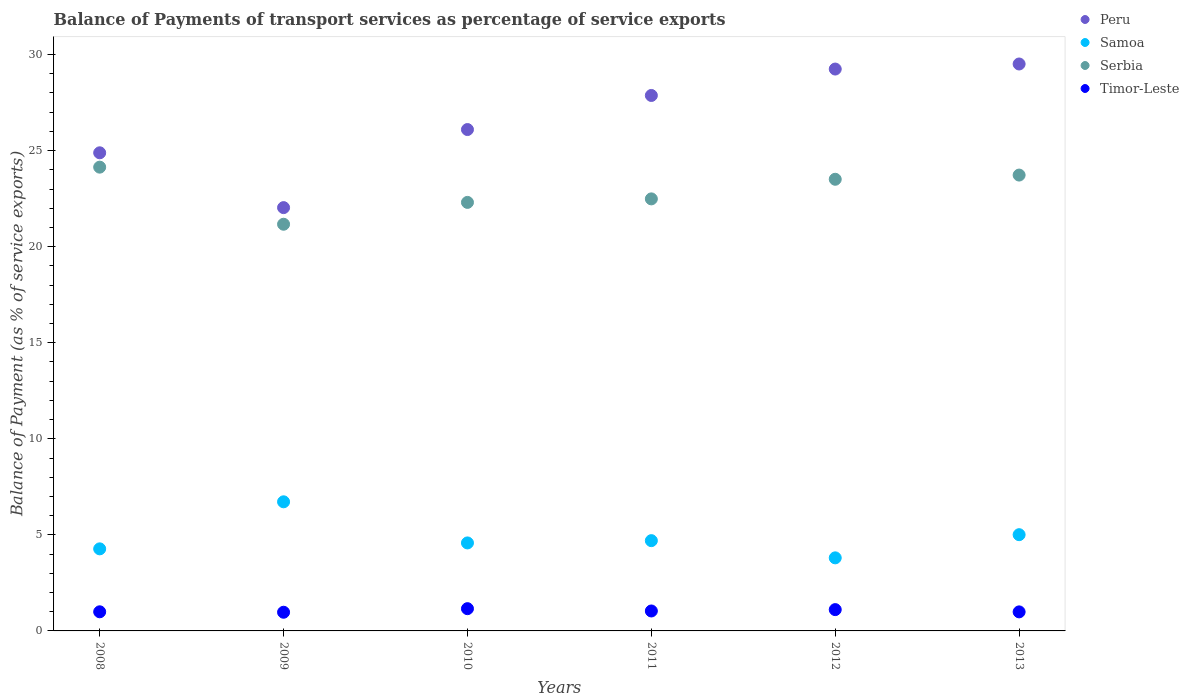Is the number of dotlines equal to the number of legend labels?
Your answer should be very brief. Yes. What is the balance of payments of transport services in Serbia in 2010?
Your answer should be compact. 22.3. Across all years, what is the maximum balance of payments of transport services in Samoa?
Provide a succinct answer. 6.72. Across all years, what is the minimum balance of payments of transport services in Peru?
Your answer should be very brief. 22.03. In which year was the balance of payments of transport services in Peru minimum?
Provide a short and direct response. 2009. What is the total balance of payments of transport services in Samoa in the graph?
Ensure brevity in your answer.  29.08. What is the difference between the balance of payments of transport services in Samoa in 2011 and that in 2013?
Give a very brief answer. -0.31. What is the difference between the balance of payments of transport services in Peru in 2011 and the balance of payments of transport services in Samoa in 2012?
Keep it short and to the point. 24.07. What is the average balance of payments of transport services in Samoa per year?
Offer a terse response. 4.85. In the year 2011, what is the difference between the balance of payments of transport services in Samoa and balance of payments of transport services in Peru?
Give a very brief answer. -23.17. What is the ratio of the balance of payments of transport services in Timor-Leste in 2010 to that in 2012?
Your answer should be compact. 1.04. Is the balance of payments of transport services in Serbia in 2010 less than that in 2013?
Offer a terse response. Yes. What is the difference between the highest and the second highest balance of payments of transport services in Peru?
Make the answer very short. 0.26. What is the difference between the highest and the lowest balance of payments of transport services in Peru?
Your answer should be very brief. 7.48. In how many years, is the balance of payments of transport services in Samoa greater than the average balance of payments of transport services in Samoa taken over all years?
Offer a terse response. 2. Is the sum of the balance of payments of transport services in Samoa in 2012 and 2013 greater than the maximum balance of payments of transport services in Timor-Leste across all years?
Offer a very short reply. Yes. How many years are there in the graph?
Ensure brevity in your answer.  6. What is the difference between two consecutive major ticks on the Y-axis?
Give a very brief answer. 5. Does the graph contain any zero values?
Ensure brevity in your answer.  No. Where does the legend appear in the graph?
Offer a very short reply. Top right. What is the title of the graph?
Make the answer very short. Balance of Payments of transport services as percentage of service exports. What is the label or title of the Y-axis?
Ensure brevity in your answer.  Balance of Payment (as % of service exports). What is the Balance of Payment (as % of service exports) of Peru in 2008?
Your answer should be compact. 24.88. What is the Balance of Payment (as % of service exports) of Samoa in 2008?
Provide a succinct answer. 4.27. What is the Balance of Payment (as % of service exports) of Serbia in 2008?
Provide a succinct answer. 24.14. What is the Balance of Payment (as % of service exports) in Timor-Leste in 2008?
Provide a succinct answer. 1. What is the Balance of Payment (as % of service exports) of Peru in 2009?
Give a very brief answer. 22.03. What is the Balance of Payment (as % of service exports) in Samoa in 2009?
Provide a short and direct response. 6.72. What is the Balance of Payment (as % of service exports) of Serbia in 2009?
Make the answer very short. 21.17. What is the Balance of Payment (as % of service exports) in Timor-Leste in 2009?
Offer a terse response. 0.97. What is the Balance of Payment (as % of service exports) in Peru in 2010?
Your answer should be very brief. 26.09. What is the Balance of Payment (as % of service exports) in Samoa in 2010?
Ensure brevity in your answer.  4.58. What is the Balance of Payment (as % of service exports) of Serbia in 2010?
Provide a short and direct response. 22.3. What is the Balance of Payment (as % of service exports) of Timor-Leste in 2010?
Offer a terse response. 1.16. What is the Balance of Payment (as % of service exports) in Peru in 2011?
Offer a very short reply. 27.87. What is the Balance of Payment (as % of service exports) of Samoa in 2011?
Make the answer very short. 4.7. What is the Balance of Payment (as % of service exports) in Serbia in 2011?
Offer a very short reply. 22.49. What is the Balance of Payment (as % of service exports) in Timor-Leste in 2011?
Make the answer very short. 1.04. What is the Balance of Payment (as % of service exports) in Peru in 2012?
Provide a short and direct response. 29.24. What is the Balance of Payment (as % of service exports) of Samoa in 2012?
Your answer should be compact. 3.8. What is the Balance of Payment (as % of service exports) of Serbia in 2012?
Make the answer very short. 23.51. What is the Balance of Payment (as % of service exports) of Timor-Leste in 2012?
Ensure brevity in your answer.  1.11. What is the Balance of Payment (as % of service exports) of Peru in 2013?
Your answer should be very brief. 29.51. What is the Balance of Payment (as % of service exports) of Samoa in 2013?
Provide a succinct answer. 5.01. What is the Balance of Payment (as % of service exports) of Serbia in 2013?
Your answer should be very brief. 23.73. What is the Balance of Payment (as % of service exports) in Timor-Leste in 2013?
Provide a short and direct response. 0.99. Across all years, what is the maximum Balance of Payment (as % of service exports) in Peru?
Make the answer very short. 29.51. Across all years, what is the maximum Balance of Payment (as % of service exports) of Samoa?
Provide a short and direct response. 6.72. Across all years, what is the maximum Balance of Payment (as % of service exports) in Serbia?
Make the answer very short. 24.14. Across all years, what is the maximum Balance of Payment (as % of service exports) in Timor-Leste?
Ensure brevity in your answer.  1.16. Across all years, what is the minimum Balance of Payment (as % of service exports) in Peru?
Your answer should be compact. 22.03. Across all years, what is the minimum Balance of Payment (as % of service exports) of Samoa?
Give a very brief answer. 3.8. Across all years, what is the minimum Balance of Payment (as % of service exports) in Serbia?
Your answer should be compact. 21.17. Across all years, what is the minimum Balance of Payment (as % of service exports) in Timor-Leste?
Your answer should be compact. 0.97. What is the total Balance of Payment (as % of service exports) of Peru in the graph?
Offer a terse response. 159.63. What is the total Balance of Payment (as % of service exports) of Samoa in the graph?
Offer a terse response. 29.08. What is the total Balance of Payment (as % of service exports) of Serbia in the graph?
Make the answer very short. 137.33. What is the total Balance of Payment (as % of service exports) of Timor-Leste in the graph?
Your response must be concise. 6.26. What is the difference between the Balance of Payment (as % of service exports) in Peru in 2008 and that in 2009?
Your response must be concise. 2.85. What is the difference between the Balance of Payment (as % of service exports) in Samoa in 2008 and that in 2009?
Provide a succinct answer. -2.45. What is the difference between the Balance of Payment (as % of service exports) in Serbia in 2008 and that in 2009?
Make the answer very short. 2.97. What is the difference between the Balance of Payment (as % of service exports) in Timor-Leste in 2008 and that in 2009?
Make the answer very short. 0.02. What is the difference between the Balance of Payment (as % of service exports) of Peru in 2008 and that in 2010?
Your response must be concise. -1.21. What is the difference between the Balance of Payment (as % of service exports) in Samoa in 2008 and that in 2010?
Ensure brevity in your answer.  -0.31. What is the difference between the Balance of Payment (as % of service exports) of Serbia in 2008 and that in 2010?
Offer a terse response. 1.83. What is the difference between the Balance of Payment (as % of service exports) of Timor-Leste in 2008 and that in 2010?
Offer a terse response. -0.16. What is the difference between the Balance of Payment (as % of service exports) in Peru in 2008 and that in 2011?
Provide a succinct answer. -2.98. What is the difference between the Balance of Payment (as % of service exports) in Samoa in 2008 and that in 2011?
Give a very brief answer. -0.43. What is the difference between the Balance of Payment (as % of service exports) of Serbia in 2008 and that in 2011?
Keep it short and to the point. 1.65. What is the difference between the Balance of Payment (as % of service exports) of Timor-Leste in 2008 and that in 2011?
Give a very brief answer. -0.04. What is the difference between the Balance of Payment (as % of service exports) in Peru in 2008 and that in 2012?
Your response must be concise. -4.36. What is the difference between the Balance of Payment (as % of service exports) of Samoa in 2008 and that in 2012?
Offer a terse response. 0.47. What is the difference between the Balance of Payment (as % of service exports) of Serbia in 2008 and that in 2012?
Offer a very short reply. 0.63. What is the difference between the Balance of Payment (as % of service exports) of Timor-Leste in 2008 and that in 2012?
Your response must be concise. -0.11. What is the difference between the Balance of Payment (as % of service exports) in Peru in 2008 and that in 2013?
Provide a short and direct response. -4.62. What is the difference between the Balance of Payment (as % of service exports) of Samoa in 2008 and that in 2013?
Your answer should be compact. -0.74. What is the difference between the Balance of Payment (as % of service exports) of Serbia in 2008 and that in 2013?
Your answer should be very brief. 0.41. What is the difference between the Balance of Payment (as % of service exports) in Timor-Leste in 2008 and that in 2013?
Your answer should be compact. 0. What is the difference between the Balance of Payment (as % of service exports) of Peru in 2009 and that in 2010?
Ensure brevity in your answer.  -4.06. What is the difference between the Balance of Payment (as % of service exports) of Samoa in 2009 and that in 2010?
Make the answer very short. 2.14. What is the difference between the Balance of Payment (as % of service exports) in Serbia in 2009 and that in 2010?
Offer a very short reply. -1.14. What is the difference between the Balance of Payment (as % of service exports) in Timor-Leste in 2009 and that in 2010?
Make the answer very short. -0.19. What is the difference between the Balance of Payment (as % of service exports) in Peru in 2009 and that in 2011?
Make the answer very short. -5.84. What is the difference between the Balance of Payment (as % of service exports) of Samoa in 2009 and that in 2011?
Keep it short and to the point. 2.02. What is the difference between the Balance of Payment (as % of service exports) of Serbia in 2009 and that in 2011?
Your answer should be very brief. -1.32. What is the difference between the Balance of Payment (as % of service exports) in Timor-Leste in 2009 and that in 2011?
Offer a very short reply. -0.07. What is the difference between the Balance of Payment (as % of service exports) of Peru in 2009 and that in 2012?
Provide a short and direct response. -7.21. What is the difference between the Balance of Payment (as % of service exports) of Samoa in 2009 and that in 2012?
Make the answer very short. 2.92. What is the difference between the Balance of Payment (as % of service exports) in Serbia in 2009 and that in 2012?
Your answer should be compact. -2.34. What is the difference between the Balance of Payment (as % of service exports) in Timor-Leste in 2009 and that in 2012?
Your answer should be compact. -0.14. What is the difference between the Balance of Payment (as % of service exports) of Peru in 2009 and that in 2013?
Offer a terse response. -7.48. What is the difference between the Balance of Payment (as % of service exports) in Samoa in 2009 and that in 2013?
Your response must be concise. 1.71. What is the difference between the Balance of Payment (as % of service exports) in Serbia in 2009 and that in 2013?
Offer a terse response. -2.56. What is the difference between the Balance of Payment (as % of service exports) of Timor-Leste in 2009 and that in 2013?
Your answer should be compact. -0.02. What is the difference between the Balance of Payment (as % of service exports) of Peru in 2010 and that in 2011?
Offer a very short reply. -1.77. What is the difference between the Balance of Payment (as % of service exports) in Samoa in 2010 and that in 2011?
Provide a short and direct response. -0.12. What is the difference between the Balance of Payment (as % of service exports) of Serbia in 2010 and that in 2011?
Provide a short and direct response. -0.18. What is the difference between the Balance of Payment (as % of service exports) of Timor-Leste in 2010 and that in 2011?
Give a very brief answer. 0.12. What is the difference between the Balance of Payment (as % of service exports) in Peru in 2010 and that in 2012?
Your answer should be very brief. -3.15. What is the difference between the Balance of Payment (as % of service exports) in Samoa in 2010 and that in 2012?
Your response must be concise. 0.78. What is the difference between the Balance of Payment (as % of service exports) of Serbia in 2010 and that in 2012?
Your answer should be compact. -1.2. What is the difference between the Balance of Payment (as % of service exports) of Timor-Leste in 2010 and that in 2012?
Offer a very short reply. 0.05. What is the difference between the Balance of Payment (as % of service exports) in Peru in 2010 and that in 2013?
Your answer should be very brief. -3.41. What is the difference between the Balance of Payment (as % of service exports) of Samoa in 2010 and that in 2013?
Offer a terse response. -0.43. What is the difference between the Balance of Payment (as % of service exports) of Serbia in 2010 and that in 2013?
Provide a short and direct response. -1.42. What is the difference between the Balance of Payment (as % of service exports) of Timor-Leste in 2010 and that in 2013?
Ensure brevity in your answer.  0.17. What is the difference between the Balance of Payment (as % of service exports) of Peru in 2011 and that in 2012?
Offer a very short reply. -1.38. What is the difference between the Balance of Payment (as % of service exports) in Samoa in 2011 and that in 2012?
Keep it short and to the point. 0.9. What is the difference between the Balance of Payment (as % of service exports) of Serbia in 2011 and that in 2012?
Ensure brevity in your answer.  -1.02. What is the difference between the Balance of Payment (as % of service exports) in Timor-Leste in 2011 and that in 2012?
Offer a terse response. -0.07. What is the difference between the Balance of Payment (as % of service exports) in Peru in 2011 and that in 2013?
Offer a very short reply. -1.64. What is the difference between the Balance of Payment (as % of service exports) in Samoa in 2011 and that in 2013?
Make the answer very short. -0.31. What is the difference between the Balance of Payment (as % of service exports) of Serbia in 2011 and that in 2013?
Your answer should be compact. -1.24. What is the difference between the Balance of Payment (as % of service exports) in Timor-Leste in 2011 and that in 2013?
Give a very brief answer. 0.05. What is the difference between the Balance of Payment (as % of service exports) in Peru in 2012 and that in 2013?
Provide a short and direct response. -0.26. What is the difference between the Balance of Payment (as % of service exports) in Samoa in 2012 and that in 2013?
Your answer should be compact. -1.21. What is the difference between the Balance of Payment (as % of service exports) in Serbia in 2012 and that in 2013?
Offer a very short reply. -0.22. What is the difference between the Balance of Payment (as % of service exports) in Timor-Leste in 2012 and that in 2013?
Keep it short and to the point. 0.12. What is the difference between the Balance of Payment (as % of service exports) in Peru in 2008 and the Balance of Payment (as % of service exports) in Samoa in 2009?
Make the answer very short. 18.16. What is the difference between the Balance of Payment (as % of service exports) of Peru in 2008 and the Balance of Payment (as % of service exports) of Serbia in 2009?
Your response must be concise. 3.72. What is the difference between the Balance of Payment (as % of service exports) in Peru in 2008 and the Balance of Payment (as % of service exports) in Timor-Leste in 2009?
Offer a terse response. 23.91. What is the difference between the Balance of Payment (as % of service exports) of Samoa in 2008 and the Balance of Payment (as % of service exports) of Serbia in 2009?
Your answer should be very brief. -16.9. What is the difference between the Balance of Payment (as % of service exports) in Samoa in 2008 and the Balance of Payment (as % of service exports) in Timor-Leste in 2009?
Provide a succinct answer. 3.3. What is the difference between the Balance of Payment (as % of service exports) in Serbia in 2008 and the Balance of Payment (as % of service exports) in Timor-Leste in 2009?
Keep it short and to the point. 23.17. What is the difference between the Balance of Payment (as % of service exports) of Peru in 2008 and the Balance of Payment (as % of service exports) of Samoa in 2010?
Ensure brevity in your answer.  20.3. What is the difference between the Balance of Payment (as % of service exports) in Peru in 2008 and the Balance of Payment (as % of service exports) in Serbia in 2010?
Provide a short and direct response. 2.58. What is the difference between the Balance of Payment (as % of service exports) of Peru in 2008 and the Balance of Payment (as % of service exports) of Timor-Leste in 2010?
Provide a succinct answer. 23.73. What is the difference between the Balance of Payment (as % of service exports) in Samoa in 2008 and the Balance of Payment (as % of service exports) in Serbia in 2010?
Provide a short and direct response. -18.03. What is the difference between the Balance of Payment (as % of service exports) in Samoa in 2008 and the Balance of Payment (as % of service exports) in Timor-Leste in 2010?
Provide a succinct answer. 3.11. What is the difference between the Balance of Payment (as % of service exports) in Serbia in 2008 and the Balance of Payment (as % of service exports) in Timor-Leste in 2010?
Your response must be concise. 22.98. What is the difference between the Balance of Payment (as % of service exports) of Peru in 2008 and the Balance of Payment (as % of service exports) of Samoa in 2011?
Make the answer very short. 20.19. What is the difference between the Balance of Payment (as % of service exports) in Peru in 2008 and the Balance of Payment (as % of service exports) in Serbia in 2011?
Ensure brevity in your answer.  2.4. What is the difference between the Balance of Payment (as % of service exports) of Peru in 2008 and the Balance of Payment (as % of service exports) of Timor-Leste in 2011?
Provide a succinct answer. 23.85. What is the difference between the Balance of Payment (as % of service exports) in Samoa in 2008 and the Balance of Payment (as % of service exports) in Serbia in 2011?
Provide a short and direct response. -18.22. What is the difference between the Balance of Payment (as % of service exports) in Samoa in 2008 and the Balance of Payment (as % of service exports) in Timor-Leste in 2011?
Provide a short and direct response. 3.23. What is the difference between the Balance of Payment (as % of service exports) of Serbia in 2008 and the Balance of Payment (as % of service exports) of Timor-Leste in 2011?
Offer a terse response. 23.1. What is the difference between the Balance of Payment (as % of service exports) of Peru in 2008 and the Balance of Payment (as % of service exports) of Samoa in 2012?
Make the answer very short. 21.08. What is the difference between the Balance of Payment (as % of service exports) in Peru in 2008 and the Balance of Payment (as % of service exports) in Serbia in 2012?
Your answer should be very brief. 1.38. What is the difference between the Balance of Payment (as % of service exports) of Peru in 2008 and the Balance of Payment (as % of service exports) of Timor-Leste in 2012?
Offer a very short reply. 23.78. What is the difference between the Balance of Payment (as % of service exports) of Samoa in 2008 and the Balance of Payment (as % of service exports) of Serbia in 2012?
Keep it short and to the point. -19.24. What is the difference between the Balance of Payment (as % of service exports) in Samoa in 2008 and the Balance of Payment (as % of service exports) in Timor-Leste in 2012?
Offer a very short reply. 3.16. What is the difference between the Balance of Payment (as % of service exports) of Serbia in 2008 and the Balance of Payment (as % of service exports) of Timor-Leste in 2012?
Ensure brevity in your answer.  23.03. What is the difference between the Balance of Payment (as % of service exports) in Peru in 2008 and the Balance of Payment (as % of service exports) in Samoa in 2013?
Make the answer very short. 19.88. What is the difference between the Balance of Payment (as % of service exports) of Peru in 2008 and the Balance of Payment (as % of service exports) of Serbia in 2013?
Provide a short and direct response. 1.16. What is the difference between the Balance of Payment (as % of service exports) in Peru in 2008 and the Balance of Payment (as % of service exports) in Timor-Leste in 2013?
Your answer should be compact. 23.89. What is the difference between the Balance of Payment (as % of service exports) of Samoa in 2008 and the Balance of Payment (as % of service exports) of Serbia in 2013?
Your answer should be very brief. -19.45. What is the difference between the Balance of Payment (as % of service exports) in Samoa in 2008 and the Balance of Payment (as % of service exports) in Timor-Leste in 2013?
Keep it short and to the point. 3.28. What is the difference between the Balance of Payment (as % of service exports) in Serbia in 2008 and the Balance of Payment (as % of service exports) in Timor-Leste in 2013?
Your answer should be compact. 23.15. What is the difference between the Balance of Payment (as % of service exports) of Peru in 2009 and the Balance of Payment (as % of service exports) of Samoa in 2010?
Provide a short and direct response. 17.45. What is the difference between the Balance of Payment (as % of service exports) in Peru in 2009 and the Balance of Payment (as % of service exports) in Serbia in 2010?
Provide a short and direct response. -0.27. What is the difference between the Balance of Payment (as % of service exports) of Peru in 2009 and the Balance of Payment (as % of service exports) of Timor-Leste in 2010?
Keep it short and to the point. 20.87. What is the difference between the Balance of Payment (as % of service exports) in Samoa in 2009 and the Balance of Payment (as % of service exports) in Serbia in 2010?
Give a very brief answer. -15.58. What is the difference between the Balance of Payment (as % of service exports) in Samoa in 2009 and the Balance of Payment (as % of service exports) in Timor-Leste in 2010?
Give a very brief answer. 5.56. What is the difference between the Balance of Payment (as % of service exports) of Serbia in 2009 and the Balance of Payment (as % of service exports) of Timor-Leste in 2010?
Keep it short and to the point. 20.01. What is the difference between the Balance of Payment (as % of service exports) in Peru in 2009 and the Balance of Payment (as % of service exports) in Samoa in 2011?
Give a very brief answer. 17.33. What is the difference between the Balance of Payment (as % of service exports) in Peru in 2009 and the Balance of Payment (as % of service exports) in Serbia in 2011?
Your answer should be compact. -0.46. What is the difference between the Balance of Payment (as % of service exports) of Peru in 2009 and the Balance of Payment (as % of service exports) of Timor-Leste in 2011?
Ensure brevity in your answer.  20.99. What is the difference between the Balance of Payment (as % of service exports) in Samoa in 2009 and the Balance of Payment (as % of service exports) in Serbia in 2011?
Your response must be concise. -15.77. What is the difference between the Balance of Payment (as % of service exports) in Samoa in 2009 and the Balance of Payment (as % of service exports) in Timor-Leste in 2011?
Provide a succinct answer. 5.68. What is the difference between the Balance of Payment (as % of service exports) of Serbia in 2009 and the Balance of Payment (as % of service exports) of Timor-Leste in 2011?
Give a very brief answer. 20.13. What is the difference between the Balance of Payment (as % of service exports) of Peru in 2009 and the Balance of Payment (as % of service exports) of Samoa in 2012?
Make the answer very short. 18.23. What is the difference between the Balance of Payment (as % of service exports) in Peru in 2009 and the Balance of Payment (as % of service exports) in Serbia in 2012?
Offer a very short reply. -1.48. What is the difference between the Balance of Payment (as % of service exports) of Peru in 2009 and the Balance of Payment (as % of service exports) of Timor-Leste in 2012?
Your answer should be very brief. 20.92. What is the difference between the Balance of Payment (as % of service exports) in Samoa in 2009 and the Balance of Payment (as % of service exports) in Serbia in 2012?
Give a very brief answer. -16.79. What is the difference between the Balance of Payment (as % of service exports) of Samoa in 2009 and the Balance of Payment (as % of service exports) of Timor-Leste in 2012?
Offer a very short reply. 5.61. What is the difference between the Balance of Payment (as % of service exports) in Serbia in 2009 and the Balance of Payment (as % of service exports) in Timor-Leste in 2012?
Keep it short and to the point. 20.06. What is the difference between the Balance of Payment (as % of service exports) of Peru in 2009 and the Balance of Payment (as % of service exports) of Samoa in 2013?
Your response must be concise. 17.02. What is the difference between the Balance of Payment (as % of service exports) of Peru in 2009 and the Balance of Payment (as % of service exports) of Serbia in 2013?
Your answer should be compact. -1.69. What is the difference between the Balance of Payment (as % of service exports) of Peru in 2009 and the Balance of Payment (as % of service exports) of Timor-Leste in 2013?
Provide a succinct answer. 21.04. What is the difference between the Balance of Payment (as % of service exports) in Samoa in 2009 and the Balance of Payment (as % of service exports) in Serbia in 2013?
Make the answer very short. -17.01. What is the difference between the Balance of Payment (as % of service exports) of Samoa in 2009 and the Balance of Payment (as % of service exports) of Timor-Leste in 2013?
Your answer should be very brief. 5.73. What is the difference between the Balance of Payment (as % of service exports) of Serbia in 2009 and the Balance of Payment (as % of service exports) of Timor-Leste in 2013?
Make the answer very short. 20.18. What is the difference between the Balance of Payment (as % of service exports) in Peru in 2010 and the Balance of Payment (as % of service exports) in Samoa in 2011?
Your response must be concise. 21.4. What is the difference between the Balance of Payment (as % of service exports) of Peru in 2010 and the Balance of Payment (as % of service exports) of Serbia in 2011?
Make the answer very short. 3.61. What is the difference between the Balance of Payment (as % of service exports) in Peru in 2010 and the Balance of Payment (as % of service exports) in Timor-Leste in 2011?
Your answer should be very brief. 25.06. What is the difference between the Balance of Payment (as % of service exports) in Samoa in 2010 and the Balance of Payment (as % of service exports) in Serbia in 2011?
Provide a short and direct response. -17.91. What is the difference between the Balance of Payment (as % of service exports) in Samoa in 2010 and the Balance of Payment (as % of service exports) in Timor-Leste in 2011?
Your answer should be very brief. 3.54. What is the difference between the Balance of Payment (as % of service exports) in Serbia in 2010 and the Balance of Payment (as % of service exports) in Timor-Leste in 2011?
Give a very brief answer. 21.27. What is the difference between the Balance of Payment (as % of service exports) of Peru in 2010 and the Balance of Payment (as % of service exports) of Samoa in 2012?
Offer a terse response. 22.29. What is the difference between the Balance of Payment (as % of service exports) in Peru in 2010 and the Balance of Payment (as % of service exports) in Serbia in 2012?
Provide a short and direct response. 2.59. What is the difference between the Balance of Payment (as % of service exports) of Peru in 2010 and the Balance of Payment (as % of service exports) of Timor-Leste in 2012?
Ensure brevity in your answer.  24.99. What is the difference between the Balance of Payment (as % of service exports) in Samoa in 2010 and the Balance of Payment (as % of service exports) in Serbia in 2012?
Make the answer very short. -18.93. What is the difference between the Balance of Payment (as % of service exports) of Samoa in 2010 and the Balance of Payment (as % of service exports) of Timor-Leste in 2012?
Provide a short and direct response. 3.47. What is the difference between the Balance of Payment (as % of service exports) of Serbia in 2010 and the Balance of Payment (as % of service exports) of Timor-Leste in 2012?
Your response must be concise. 21.19. What is the difference between the Balance of Payment (as % of service exports) of Peru in 2010 and the Balance of Payment (as % of service exports) of Samoa in 2013?
Offer a very short reply. 21.09. What is the difference between the Balance of Payment (as % of service exports) in Peru in 2010 and the Balance of Payment (as % of service exports) in Serbia in 2013?
Provide a short and direct response. 2.37. What is the difference between the Balance of Payment (as % of service exports) in Peru in 2010 and the Balance of Payment (as % of service exports) in Timor-Leste in 2013?
Provide a short and direct response. 25.1. What is the difference between the Balance of Payment (as % of service exports) of Samoa in 2010 and the Balance of Payment (as % of service exports) of Serbia in 2013?
Ensure brevity in your answer.  -19.15. What is the difference between the Balance of Payment (as % of service exports) of Samoa in 2010 and the Balance of Payment (as % of service exports) of Timor-Leste in 2013?
Provide a succinct answer. 3.59. What is the difference between the Balance of Payment (as % of service exports) in Serbia in 2010 and the Balance of Payment (as % of service exports) in Timor-Leste in 2013?
Keep it short and to the point. 21.31. What is the difference between the Balance of Payment (as % of service exports) in Peru in 2011 and the Balance of Payment (as % of service exports) in Samoa in 2012?
Your response must be concise. 24.07. What is the difference between the Balance of Payment (as % of service exports) of Peru in 2011 and the Balance of Payment (as % of service exports) of Serbia in 2012?
Provide a short and direct response. 4.36. What is the difference between the Balance of Payment (as % of service exports) in Peru in 2011 and the Balance of Payment (as % of service exports) in Timor-Leste in 2012?
Your response must be concise. 26.76. What is the difference between the Balance of Payment (as % of service exports) in Samoa in 2011 and the Balance of Payment (as % of service exports) in Serbia in 2012?
Ensure brevity in your answer.  -18.81. What is the difference between the Balance of Payment (as % of service exports) of Samoa in 2011 and the Balance of Payment (as % of service exports) of Timor-Leste in 2012?
Give a very brief answer. 3.59. What is the difference between the Balance of Payment (as % of service exports) of Serbia in 2011 and the Balance of Payment (as % of service exports) of Timor-Leste in 2012?
Your response must be concise. 21.38. What is the difference between the Balance of Payment (as % of service exports) in Peru in 2011 and the Balance of Payment (as % of service exports) in Samoa in 2013?
Offer a terse response. 22.86. What is the difference between the Balance of Payment (as % of service exports) of Peru in 2011 and the Balance of Payment (as % of service exports) of Serbia in 2013?
Make the answer very short. 4.14. What is the difference between the Balance of Payment (as % of service exports) in Peru in 2011 and the Balance of Payment (as % of service exports) in Timor-Leste in 2013?
Your answer should be very brief. 26.88. What is the difference between the Balance of Payment (as % of service exports) in Samoa in 2011 and the Balance of Payment (as % of service exports) in Serbia in 2013?
Ensure brevity in your answer.  -19.03. What is the difference between the Balance of Payment (as % of service exports) of Samoa in 2011 and the Balance of Payment (as % of service exports) of Timor-Leste in 2013?
Offer a very short reply. 3.71. What is the difference between the Balance of Payment (as % of service exports) of Serbia in 2011 and the Balance of Payment (as % of service exports) of Timor-Leste in 2013?
Your answer should be very brief. 21.5. What is the difference between the Balance of Payment (as % of service exports) of Peru in 2012 and the Balance of Payment (as % of service exports) of Samoa in 2013?
Ensure brevity in your answer.  24.23. What is the difference between the Balance of Payment (as % of service exports) in Peru in 2012 and the Balance of Payment (as % of service exports) in Serbia in 2013?
Provide a short and direct response. 5.52. What is the difference between the Balance of Payment (as % of service exports) of Peru in 2012 and the Balance of Payment (as % of service exports) of Timor-Leste in 2013?
Provide a succinct answer. 28.25. What is the difference between the Balance of Payment (as % of service exports) in Samoa in 2012 and the Balance of Payment (as % of service exports) in Serbia in 2013?
Your answer should be compact. -19.92. What is the difference between the Balance of Payment (as % of service exports) in Samoa in 2012 and the Balance of Payment (as % of service exports) in Timor-Leste in 2013?
Provide a short and direct response. 2.81. What is the difference between the Balance of Payment (as % of service exports) in Serbia in 2012 and the Balance of Payment (as % of service exports) in Timor-Leste in 2013?
Provide a succinct answer. 22.52. What is the average Balance of Payment (as % of service exports) of Peru per year?
Give a very brief answer. 26.61. What is the average Balance of Payment (as % of service exports) in Samoa per year?
Your answer should be compact. 4.85. What is the average Balance of Payment (as % of service exports) in Serbia per year?
Your answer should be compact. 22.89. What is the average Balance of Payment (as % of service exports) in Timor-Leste per year?
Your answer should be very brief. 1.04. In the year 2008, what is the difference between the Balance of Payment (as % of service exports) of Peru and Balance of Payment (as % of service exports) of Samoa?
Give a very brief answer. 20.61. In the year 2008, what is the difference between the Balance of Payment (as % of service exports) in Peru and Balance of Payment (as % of service exports) in Serbia?
Your answer should be compact. 0.75. In the year 2008, what is the difference between the Balance of Payment (as % of service exports) of Peru and Balance of Payment (as % of service exports) of Timor-Leste?
Ensure brevity in your answer.  23.89. In the year 2008, what is the difference between the Balance of Payment (as % of service exports) in Samoa and Balance of Payment (as % of service exports) in Serbia?
Provide a short and direct response. -19.87. In the year 2008, what is the difference between the Balance of Payment (as % of service exports) of Samoa and Balance of Payment (as % of service exports) of Timor-Leste?
Your answer should be very brief. 3.28. In the year 2008, what is the difference between the Balance of Payment (as % of service exports) of Serbia and Balance of Payment (as % of service exports) of Timor-Leste?
Your answer should be compact. 23.14. In the year 2009, what is the difference between the Balance of Payment (as % of service exports) in Peru and Balance of Payment (as % of service exports) in Samoa?
Make the answer very short. 15.31. In the year 2009, what is the difference between the Balance of Payment (as % of service exports) of Peru and Balance of Payment (as % of service exports) of Serbia?
Your answer should be compact. 0.86. In the year 2009, what is the difference between the Balance of Payment (as % of service exports) of Peru and Balance of Payment (as % of service exports) of Timor-Leste?
Your answer should be very brief. 21.06. In the year 2009, what is the difference between the Balance of Payment (as % of service exports) in Samoa and Balance of Payment (as % of service exports) in Serbia?
Your answer should be very brief. -14.45. In the year 2009, what is the difference between the Balance of Payment (as % of service exports) in Samoa and Balance of Payment (as % of service exports) in Timor-Leste?
Ensure brevity in your answer.  5.75. In the year 2009, what is the difference between the Balance of Payment (as % of service exports) of Serbia and Balance of Payment (as % of service exports) of Timor-Leste?
Your answer should be compact. 20.19. In the year 2010, what is the difference between the Balance of Payment (as % of service exports) in Peru and Balance of Payment (as % of service exports) in Samoa?
Your response must be concise. 21.52. In the year 2010, what is the difference between the Balance of Payment (as % of service exports) in Peru and Balance of Payment (as % of service exports) in Serbia?
Offer a very short reply. 3.79. In the year 2010, what is the difference between the Balance of Payment (as % of service exports) of Peru and Balance of Payment (as % of service exports) of Timor-Leste?
Offer a terse response. 24.94. In the year 2010, what is the difference between the Balance of Payment (as % of service exports) of Samoa and Balance of Payment (as % of service exports) of Serbia?
Offer a terse response. -17.72. In the year 2010, what is the difference between the Balance of Payment (as % of service exports) of Samoa and Balance of Payment (as % of service exports) of Timor-Leste?
Offer a very short reply. 3.42. In the year 2010, what is the difference between the Balance of Payment (as % of service exports) of Serbia and Balance of Payment (as % of service exports) of Timor-Leste?
Give a very brief answer. 21.15. In the year 2011, what is the difference between the Balance of Payment (as % of service exports) of Peru and Balance of Payment (as % of service exports) of Samoa?
Offer a very short reply. 23.17. In the year 2011, what is the difference between the Balance of Payment (as % of service exports) in Peru and Balance of Payment (as % of service exports) in Serbia?
Provide a succinct answer. 5.38. In the year 2011, what is the difference between the Balance of Payment (as % of service exports) in Peru and Balance of Payment (as % of service exports) in Timor-Leste?
Keep it short and to the point. 26.83. In the year 2011, what is the difference between the Balance of Payment (as % of service exports) of Samoa and Balance of Payment (as % of service exports) of Serbia?
Ensure brevity in your answer.  -17.79. In the year 2011, what is the difference between the Balance of Payment (as % of service exports) in Samoa and Balance of Payment (as % of service exports) in Timor-Leste?
Give a very brief answer. 3.66. In the year 2011, what is the difference between the Balance of Payment (as % of service exports) of Serbia and Balance of Payment (as % of service exports) of Timor-Leste?
Offer a terse response. 21.45. In the year 2012, what is the difference between the Balance of Payment (as % of service exports) in Peru and Balance of Payment (as % of service exports) in Samoa?
Give a very brief answer. 25.44. In the year 2012, what is the difference between the Balance of Payment (as % of service exports) of Peru and Balance of Payment (as % of service exports) of Serbia?
Offer a terse response. 5.74. In the year 2012, what is the difference between the Balance of Payment (as % of service exports) of Peru and Balance of Payment (as % of service exports) of Timor-Leste?
Offer a very short reply. 28.13. In the year 2012, what is the difference between the Balance of Payment (as % of service exports) of Samoa and Balance of Payment (as % of service exports) of Serbia?
Your answer should be compact. -19.7. In the year 2012, what is the difference between the Balance of Payment (as % of service exports) of Samoa and Balance of Payment (as % of service exports) of Timor-Leste?
Ensure brevity in your answer.  2.69. In the year 2012, what is the difference between the Balance of Payment (as % of service exports) in Serbia and Balance of Payment (as % of service exports) in Timor-Leste?
Offer a terse response. 22.4. In the year 2013, what is the difference between the Balance of Payment (as % of service exports) of Peru and Balance of Payment (as % of service exports) of Samoa?
Your answer should be compact. 24.5. In the year 2013, what is the difference between the Balance of Payment (as % of service exports) in Peru and Balance of Payment (as % of service exports) in Serbia?
Provide a short and direct response. 5.78. In the year 2013, what is the difference between the Balance of Payment (as % of service exports) of Peru and Balance of Payment (as % of service exports) of Timor-Leste?
Provide a succinct answer. 28.52. In the year 2013, what is the difference between the Balance of Payment (as % of service exports) of Samoa and Balance of Payment (as % of service exports) of Serbia?
Make the answer very short. -18.72. In the year 2013, what is the difference between the Balance of Payment (as % of service exports) in Samoa and Balance of Payment (as % of service exports) in Timor-Leste?
Your answer should be compact. 4.02. In the year 2013, what is the difference between the Balance of Payment (as % of service exports) of Serbia and Balance of Payment (as % of service exports) of Timor-Leste?
Give a very brief answer. 22.73. What is the ratio of the Balance of Payment (as % of service exports) in Peru in 2008 to that in 2009?
Give a very brief answer. 1.13. What is the ratio of the Balance of Payment (as % of service exports) of Samoa in 2008 to that in 2009?
Your response must be concise. 0.64. What is the ratio of the Balance of Payment (as % of service exports) of Serbia in 2008 to that in 2009?
Provide a short and direct response. 1.14. What is the ratio of the Balance of Payment (as % of service exports) in Timor-Leste in 2008 to that in 2009?
Your answer should be very brief. 1.02. What is the ratio of the Balance of Payment (as % of service exports) in Peru in 2008 to that in 2010?
Make the answer very short. 0.95. What is the ratio of the Balance of Payment (as % of service exports) in Samoa in 2008 to that in 2010?
Provide a short and direct response. 0.93. What is the ratio of the Balance of Payment (as % of service exports) in Serbia in 2008 to that in 2010?
Make the answer very short. 1.08. What is the ratio of the Balance of Payment (as % of service exports) in Timor-Leste in 2008 to that in 2010?
Ensure brevity in your answer.  0.86. What is the ratio of the Balance of Payment (as % of service exports) of Peru in 2008 to that in 2011?
Provide a short and direct response. 0.89. What is the ratio of the Balance of Payment (as % of service exports) in Serbia in 2008 to that in 2011?
Keep it short and to the point. 1.07. What is the ratio of the Balance of Payment (as % of service exports) in Timor-Leste in 2008 to that in 2011?
Your answer should be compact. 0.96. What is the ratio of the Balance of Payment (as % of service exports) of Peru in 2008 to that in 2012?
Keep it short and to the point. 0.85. What is the ratio of the Balance of Payment (as % of service exports) in Samoa in 2008 to that in 2012?
Keep it short and to the point. 1.12. What is the ratio of the Balance of Payment (as % of service exports) of Serbia in 2008 to that in 2012?
Your response must be concise. 1.03. What is the ratio of the Balance of Payment (as % of service exports) of Timor-Leste in 2008 to that in 2012?
Your answer should be very brief. 0.9. What is the ratio of the Balance of Payment (as % of service exports) in Peru in 2008 to that in 2013?
Make the answer very short. 0.84. What is the ratio of the Balance of Payment (as % of service exports) in Samoa in 2008 to that in 2013?
Your answer should be very brief. 0.85. What is the ratio of the Balance of Payment (as % of service exports) in Serbia in 2008 to that in 2013?
Give a very brief answer. 1.02. What is the ratio of the Balance of Payment (as % of service exports) of Timor-Leste in 2008 to that in 2013?
Offer a very short reply. 1. What is the ratio of the Balance of Payment (as % of service exports) in Peru in 2009 to that in 2010?
Your response must be concise. 0.84. What is the ratio of the Balance of Payment (as % of service exports) of Samoa in 2009 to that in 2010?
Provide a short and direct response. 1.47. What is the ratio of the Balance of Payment (as % of service exports) in Serbia in 2009 to that in 2010?
Your response must be concise. 0.95. What is the ratio of the Balance of Payment (as % of service exports) in Timor-Leste in 2009 to that in 2010?
Give a very brief answer. 0.84. What is the ratio of the Balance of Payment (as % of service exports) of Peru in 2009 to that in 2011?
Provide a short and direct response. 0.79. What is the ratio of the Balance of Payment (as % of service exports) in Samoa in 2009 to that in 2011?
Make the answer very short. 1.43. What is the ratio of the Balance of Payment (as % of service exports) of Serbia in 2009 to that in 2011?
Keep it short and to the point. 0.94. What is the ratio of the Balance of Payment (as % of service exports) in Timor-Leste in 2009 to that in 2011?
Your response must be concise. 0.94. What is the ratio of the Balance of Payment (as % of service exports) of Peru in 2009 to that in 2012?
Ensure brevity in your answer.  0.75. What is the ratio of the Balance of Payment (as % of service exports) of Samoa in 2009 to that in 2012?
Offer a very short reply. 1.77. What is the ratio of the Balance of Payment (as % of service exports) in Serbia in 2009 to that in 2012?
Offer a terse response. 0.9. What is the ratio of the Balance of Payment (as % of service exports) in Timor-Leste in 2009 to that in 2012?
Make the answer very short. 0.88. What is the ratio of the Balance of Payment (as % of service exports) of Peru in 2009 to that in 2013?
Keep it short and to the point. 0.75. What is the ratio of the Balance of Payment (as % of service exports) in Samoa in 2009 to that in 2013?
Offer a terse response. 1.34. What is the ratio of the Balance of Payment (as % of service exports) in Serbia in 2009 to that in 2013?
Offer a terse response. 0.89. What is the ratio of the Balance of Payment (as % of service exports) in Timor-Leste in 2009 to that in 2013?
Make the answer very short. 0.98. What is the ratio of the Balance of Payment (as % of service exports) in Peru in 2010 to that in 2011?
Your response must be concise. 0.94. What is the ratio of the Balance of Payment (as % of service exports) of Samoa in 2010 to that in 2011?
Provide a succinct answer. 0.97. What is the ratio of the Balance of Payment (as % of service exports) of Serbia in 2010 to that in 2011?
Offer a very short reply. 0.99. What is the ratio of the Balance of Payment (as % of service exports) in Timor-Leste in 2010 to that in 2011?
Provide a short and direct response. 1.12. What is the ratio of the Balance of Payment (as % of service exports) of Peru in 2010 to that in 2012?
Your answer should be very brief. 0.89. What is the ratio of the Balance of Payment (as % of service exports) in Samoa in 2010 to that in 2012?
Offer a terse response. 1.2. What is the ratio of the Balance of Payment (as % of service exports) of Serbia in 2010 to that in 2012?
Give a very brief answer. 0.95. What is the ratio of the Balance of Payment (as % of service exports) in Timor-Leste in 2010 to that in 2012?
Your response must be concise. 1.04. What is the ratio of the Balance of Payment (as % of service exports) of Peru in 2010 to that in 2013?
Provide a succinct answer. 0.88. What is the ratio of the Balance of Payment (as % of service exports) of Samoa in 2010 to that in 2013?
Your answer should be very brief. 0.91. What is the ratio of the Balance of Payment (as % of service exports) in Serbia in 2010 to that in 2013?
Provide a short and direct response. 0.94. What is the ratio of the Balance of Payment (as % of service exports) in Timor-Leste in 2010 to that in 2013?
Offer a terse response. 1.17. What is the ratio of the Balance of Payment (as % of service exports) of Peru in 2011 to that in 2012?
Ensure brevity in your answer.  0.95. What is the ratio of the Balance of Payment (as % of service exports) in Samoa in 2011 to that in 2012?
Keep it short and to the point. 1.24. What is the ratio of the Balance of Payment (as % of service exports) in Serbia in 2011 to that in 2012?
Give a very brief answer. 0.96. What is the ratio of the Balance of Payment (as % of service exports) of Timor-Leste in 2011 to that in 2012?
Ensure brevity in your answer.  0.94. What is the ratio of the Balance of Payment (as % of service exports) in Peru in 2011 to that in 2013?
Your answer should be compact. 0.94. What is the ratio of the Balance of Payment (as % of service exports) of Samoa in 2011 to that in 2013?
Your answer should be very brief. 0.94. What is the ratio of the Balance of Payment (as % of service exports) of Serbia in 2011 to that in 2013?
Ensure brevity in your answer.  0.95. What is the ratio of the Balance of Payment (as % of service exports) of Timor-Leste in 2011 to that in 2013?
Give a very brief answer. 1.05. What is the ratio of the Balance of Payment (as % of service exports) of Samoa in 2012 to that in 2013?
Provide a short and direct response. 0.76. What is the ratio of the Balance of Payment (as % of service exports) in Serbia in 2012 to that in 2013?
Provide a short and direct response. 0.99. What is the ratio of the Balance of Payment (as % of service exports) of Timor-Leste in 2012 to that in 2013?
Offer a terse response. 1.12. What is the difference between the highest and the second highest Balance of Payment (as % of service exports) of Peru?
Ensure brevity in your answer.  0.26. What is the difference between the highest and the second highest Balance of Payment (as % of service exports) of Samoa?
Offer a terse response. 1.71. What is the difference between the highest and the second highest Balance of Payment (as % of service exports) of Serbia?
Offer a very short reply. 0.41. What is the difference between the highest and the second highest Balance of Payment (as % of service exports) of Timor-Leste?
Provide a short and direct response. 0.05. What is the difference between the highest and the lowest Balance of Payment (as % of service exports) of Peru?
Ensure brevity in your answer.  7.48. What is the difference between the highest and the lowest Balance of Payment (as % of service exports) in Samoa?
Provide a short and direct response. 2.92. What is the difference between the highest and the lowest Balance of Payment (as % of service exports) of Serbia?
Offer a terse response. 2.97. What is the difference between the highest and the lowest Balance of Payment (as % of service exports) of Timor-Leste?
Offer a very short reply. 0.19. 